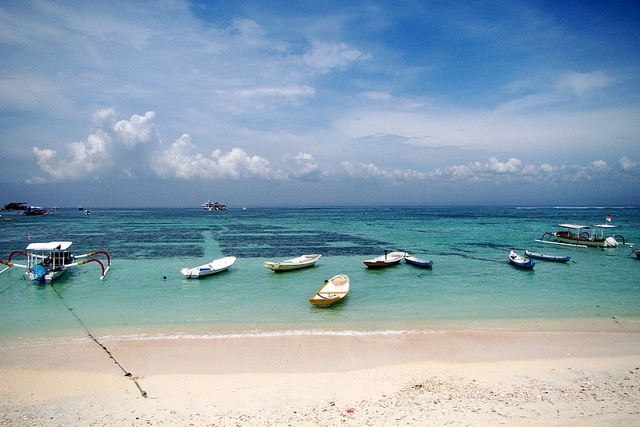Describe the objects in this image and their specific colors. I can see boat in gray, black, white, blue, and teal tones, boat in gray, teal, and black tones, boat in gray, white, olive, tan, and black tones, boat in gray, white, black, teal, and darkgray tones, and boat in gray, lightgray, black, darkgray, and darkgreen tones in this image. 